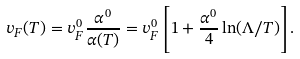Convert formula to latex. <formula><loc_0><loc_0><loc_500><loc_500>v _ { F } ( T ) = v _ { F } ^ { 0 } \frac { \alpha ^ { 0 } } { \alpha ( T ) } = v _ { F } ^ { 0 } \left [ 1 + \frac { \alpha ^ { 0 } } { 4 } \ln ( \Lambda / T ) \right ] .</formula> 